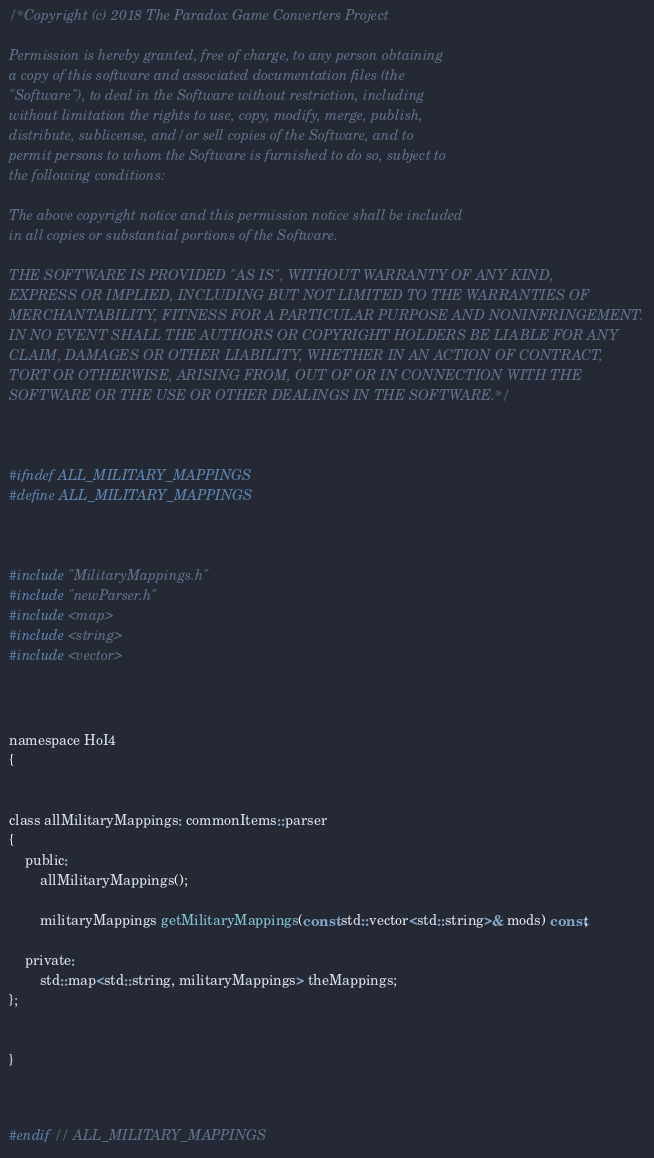<code> <loc_0><loc_0><loc_500><loc_500><_C_>/*Copyright (c) 2018 The Paradox Game Converters Project

Permission is hereby granted, free of charge, to any person obtaining
a copy of this software and associated documentation files (the
"Software"), to deal in the Software without restriction, including
without limitation the rights to use, copy, modify, merge, publish,
distribute, sublicense, and/or sell copies of the Software, and to
permit persons to whom the Software is furnished to do so, subject to
the following conditions:

The above copyright notice and this permission notice shall be included
in all copies or substantial portions of the Software.

THE SOFTWARE IS PROVIDED "AS IS", WITHOUT WARRANTY OF ANY KIND,
EXPRESS OR IMPLIED, INCLUDING BUT NOT LIMITED TO THE WARRANTIES OF
MERCHANTABILITY, FITNESS FOR A PARTICULAR PURPOSE AND NONINFRINGEMENT.
IN NO EVENT SHALL THE AUTHORS OR COPYRIGHT HOLDERS BE LIABLE FOR ANY
CLAIM, DAMAGES OR OTHER LIABILITY, WHETHER IN AN ACTION OF CONTRACT,
TORT OR OTHERWISE, ARISING FROM, OUT OF OR IN CONNECTION WITH THE
SOFTWARE OR THE USE OR OTHER DEALINGS IN THE SOFTWARE.*/



#ifndef ALL_MILITARY_MAPPINGS
#define ALL_MILITARY_MAPPINGS



#include "MilitaryMappings.h"
#include "newParser.h"
#include <map>
#include <string>
#include <vector>



namespace HoI4
{


class allMilitaryMappings: commonItems::parser
{
	public:
		allMilitaryMappings();

		militaryMappings getMilitaryMappings(const std::vector<std::string>& mods) const;

	private:
		std::map<std::string, militaryMappings> theMappings;
};


}



#endif // ALL_MILITARY_MAPPINGS</code> 